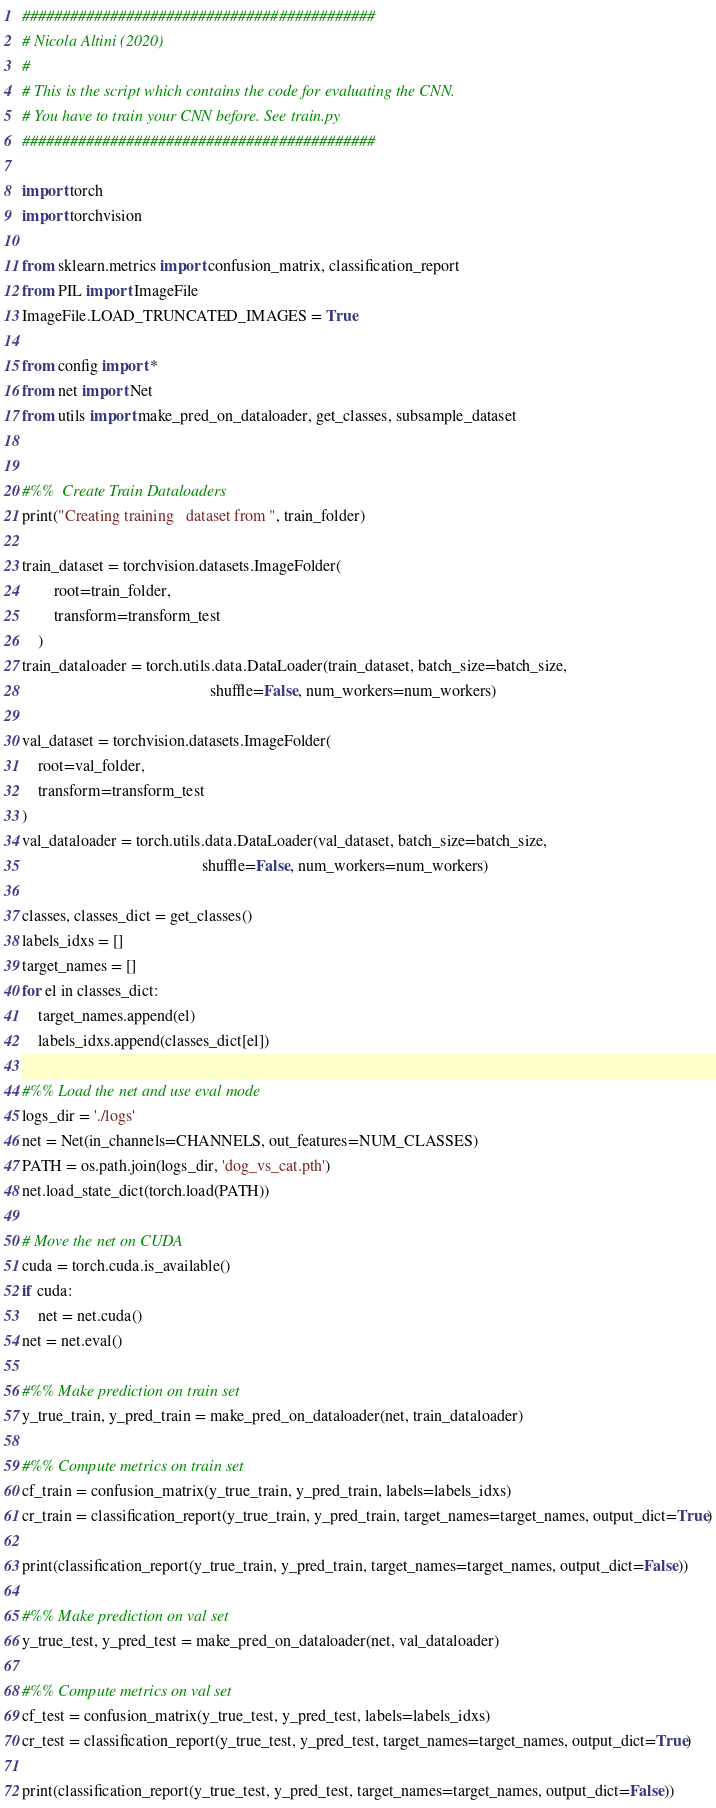<code> <loc_0><loc_0><loc_500><loc_500><_Python_>############################################
# Nicola Altini (2020)
#
# This is the script which contains the code for evaluating the CNN.
# You have to train your CNN before. See train.py
############################################

import torch
import torchvision

from sklearn.metrics import confusion_matrix, classification_report
from PIL import ImageFile
ImageFile.LOAD_TRUNCATED_IMAGES = True

from config import *
from net import Net
from utils import make_pred_on_dataloader, get_classes, subsample_dataset


#%%  Create Train Dataloaders
print("Creating training   dataset from ", train_folder)

train_dataset = torchvision.datasets.ImageFolder(
        root=train_folder,
        transform=transform_test
    )
train_dataloader = torch.utils.data.DataLoader(train_dataset, batch_size=batch_size,
                                               shuffle=False, num_workers=num_workers)

val_dataset = torchvision.datasets.ImageFolder(
    root=val_folder,
    transform=transform_test
)
val_dataloader = torch.utils.data.DataLoader(val_dataset, batch_size=batch_size,
                                             shuffle=False, num_workers=num_workers)

classes, classes_dict = get_classes()
labels_idxs = []
target_names = []
for el in classes_dict:
    target_names.append(el)
    labels_idxs.append(classes_dict[el])

#%% Load the net and use eval mode
logs_dir = './logs'
net = Net(in_channels=CHANNELS, out_features=NUM_CLASSES)
PATH = os.path.join(logs_dir, 'dog_vs_cat.pth')
net.load_state_dict(torch.load(PATH))

# Move the net on CUDA
cuda = torch.cuda.is_available()
if cuda:
    net = net.cuda()
net = net.eval()

#%% Make prediction on train set
y_true_train, y_pred_train = make_pred_on_dataloader(net, train_dataloader)

#%% Compute metrics on train set
cf_train = confusion_matrix(y_true_train, y_pred_train, labels=labels_idxs)
cr_train = classification_report(y_true_train, y_pred_train, target_names=target_names, output_dict=True)

print(classification_report(y_true_train, y_pred_train, target_names=target_names, output_dict=False))

#%% Make prediction on val set
y_true_test, y_pred_test = make_pred_on_dataloader(net, val_dataloader)

#%% Compute metrics on val set
cf_test = confusion_matrix(y_true_test, y_pred_test, labels=labels_idxs)
cr_test = classification_report(y_true_test, y_pred_test, target_names=target_names, output_dict=True)

print(classification_report(y_true_test, y_pred_test, target_names=target_names, output_dict=False))</code> 